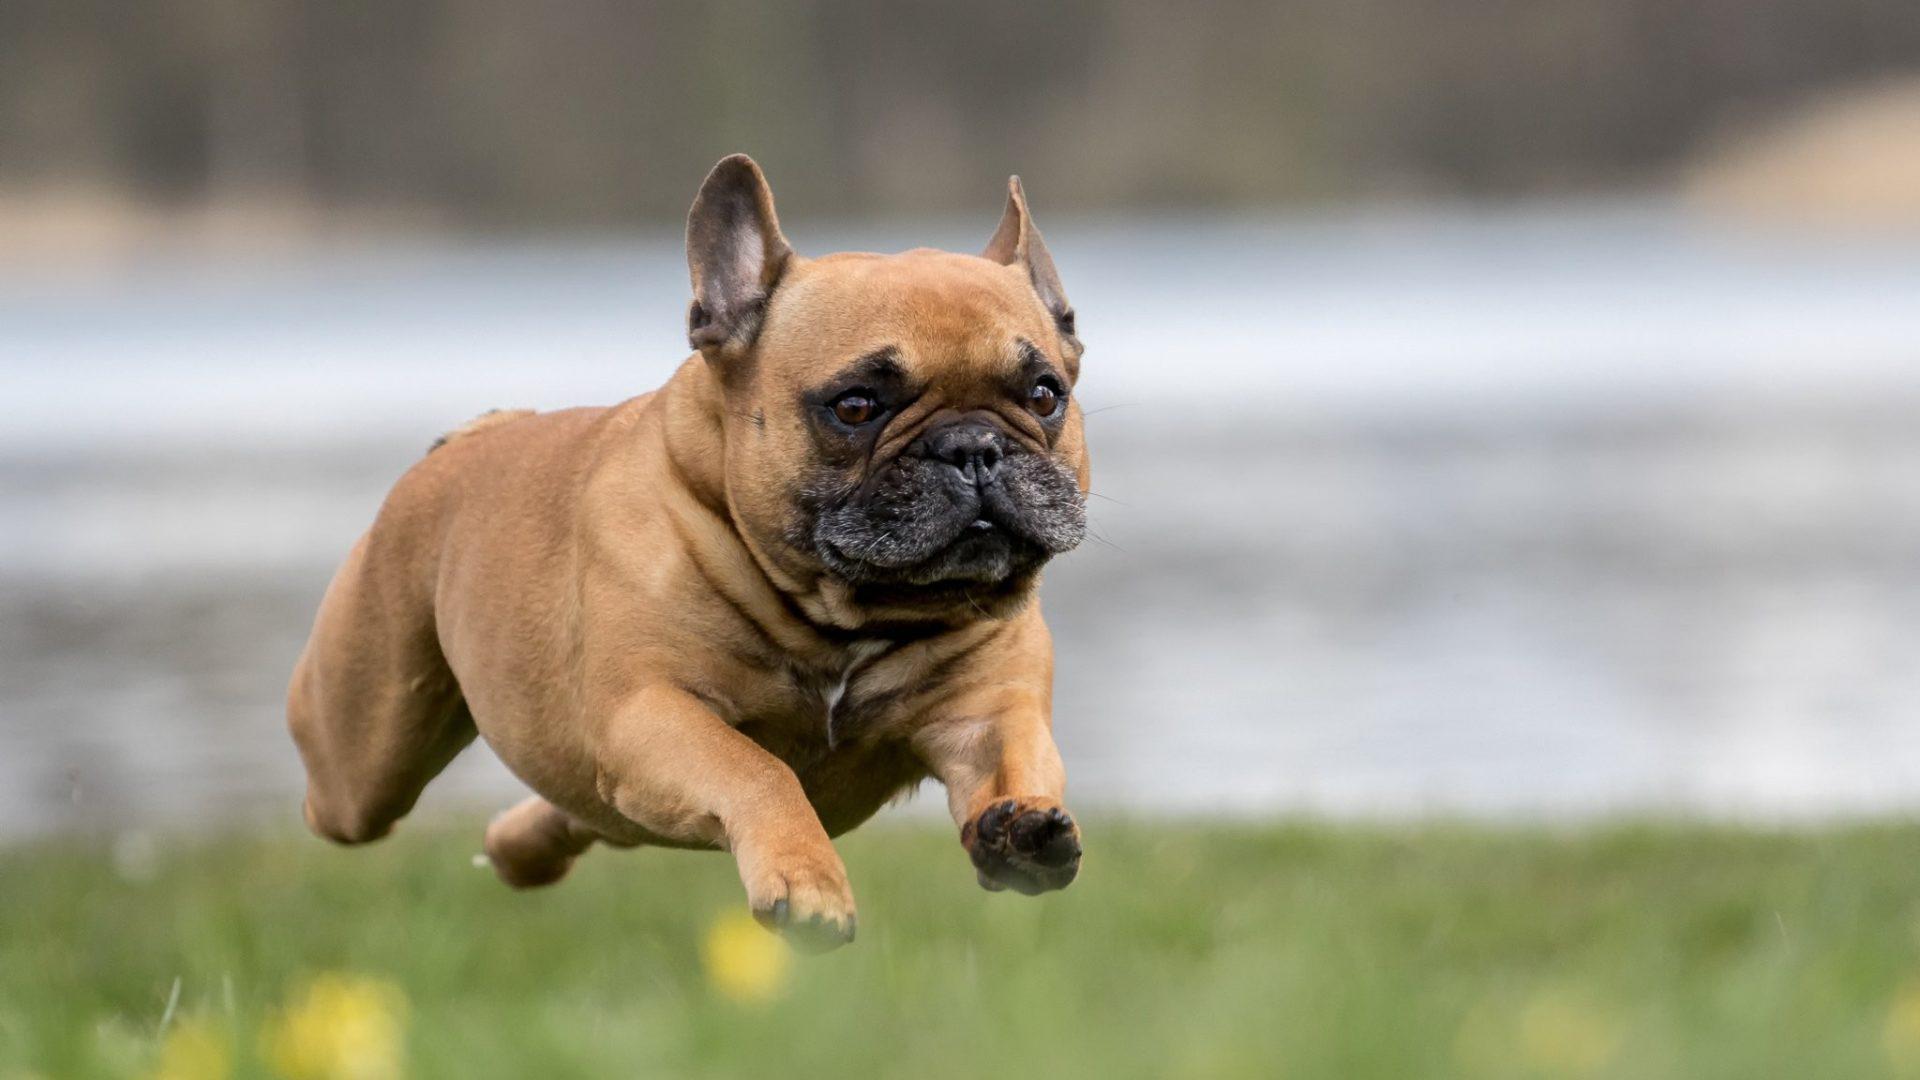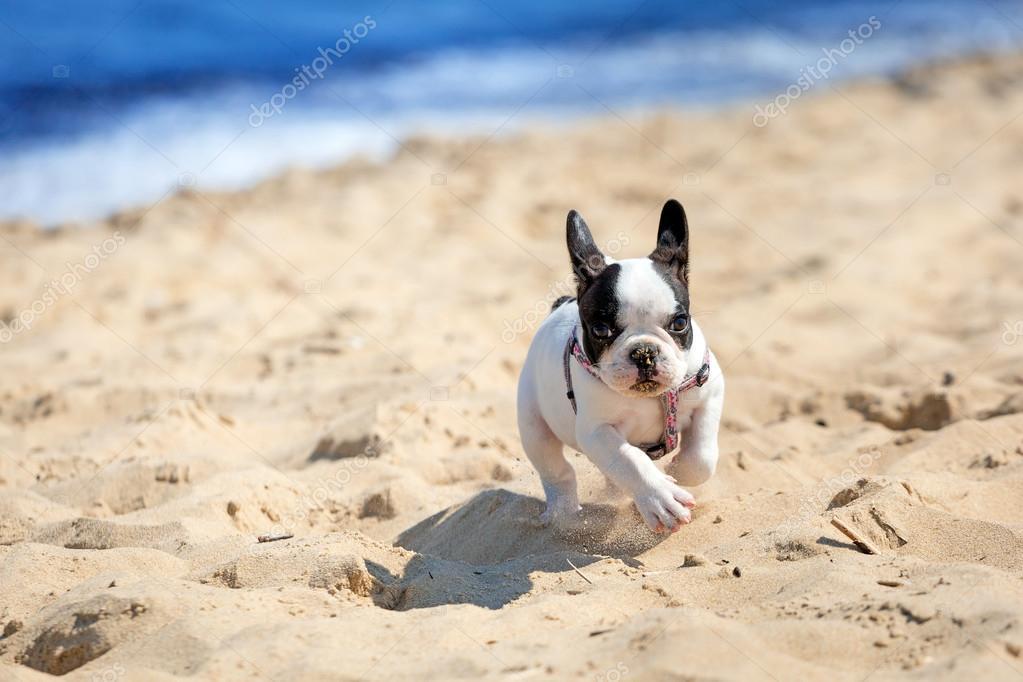The first image is the image on the left, the second image is the image on the right. Examine the images to the left and right. Is the description "The right image shows a black and white french bulldog puppy running on sand" accurate? Answer yes or no. Yes. The first image is the image on the left, the second image is the image on the right. Given the left and right images, does the statement "A single white and black dog is running in the sand." hold true? Answer yes or no. Yes. 